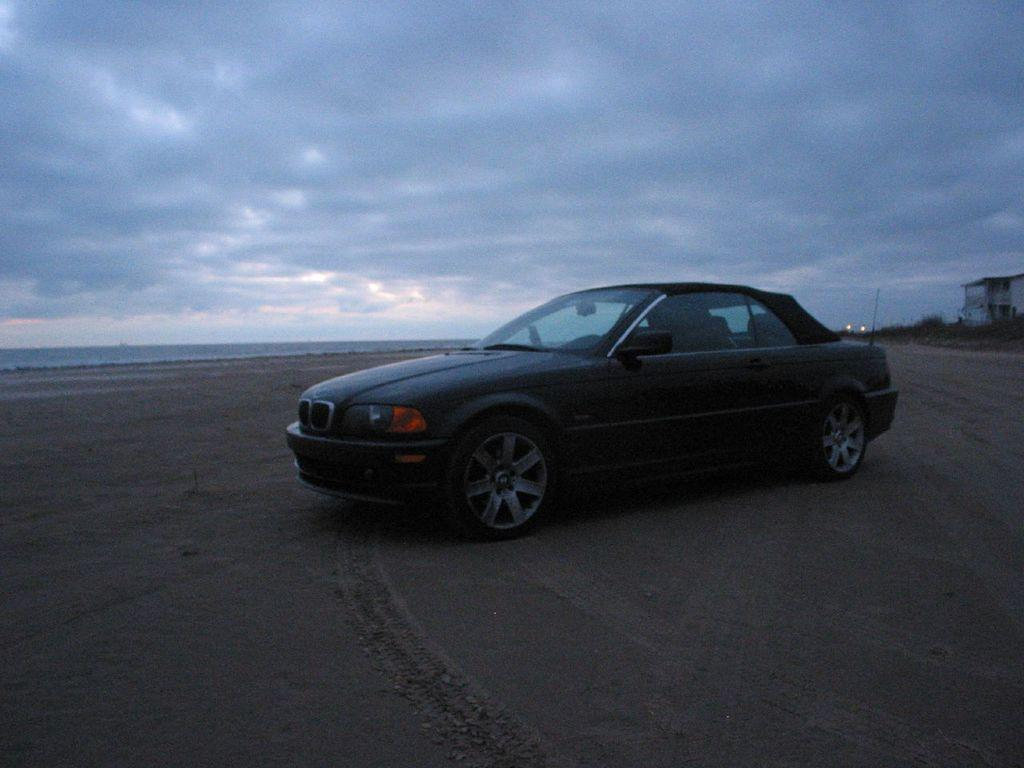What is the main subject in the image? There is a vehicle in the image. What can be seen beneath the vehicle? The ground is visible in the image. What is located on the right side of the image? There are objects on the right side of the image. What is visible above the vehicle and objects? The sky is visible in the image. What can be observed in the sky? Clouds are present in the sky. What type of pen can be seen in the image? There is no pen present in the image. How many grapes are visible on the vehicle? There are no grapes visible in the image. 